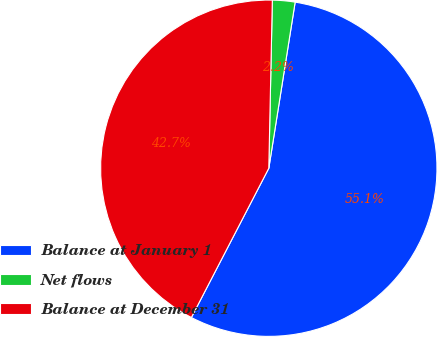Convert chart to OTSL. <chart><loc_0><loc_0><loc_500><loc_500><pie_chart><fcel>Balance at January 1<fcel>Net flows<fcel>Balance at December 31<nl><fcel>55.11%<fcel>2.17%<fcel>42.72%<nl></chart> 